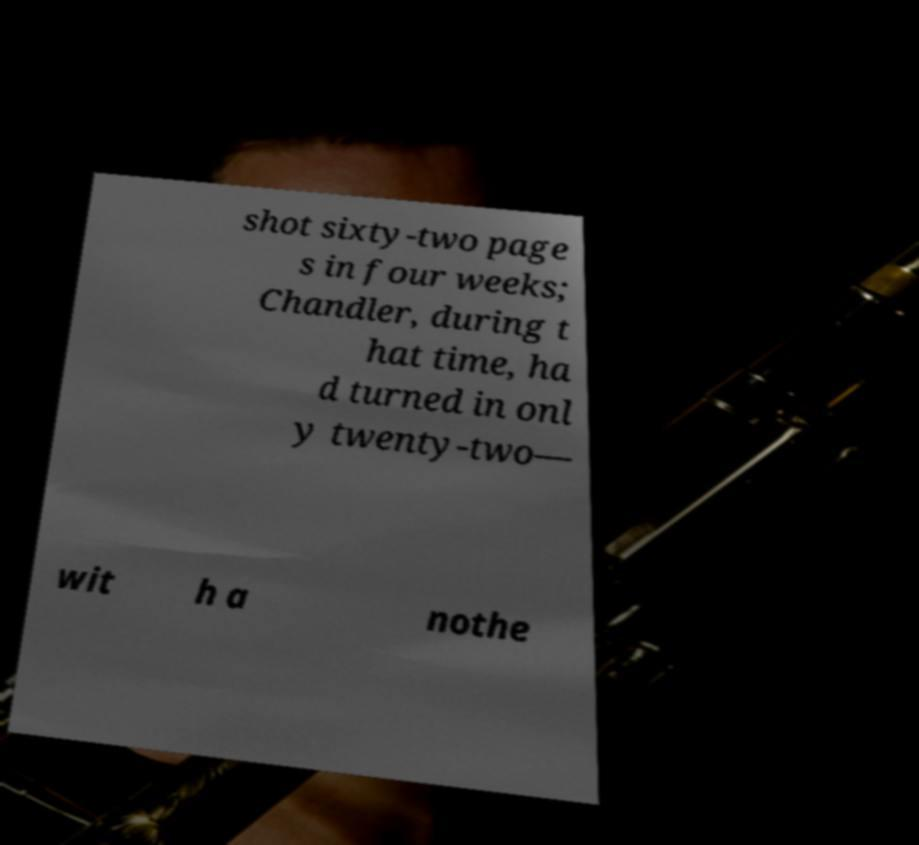Could you assist in decoding the text presented in this image and type it out clearly? shot sixty-two page s in four weeks; Chandler, during t hat time, ha d turned in onl y twenty-two— wit h a nothe 